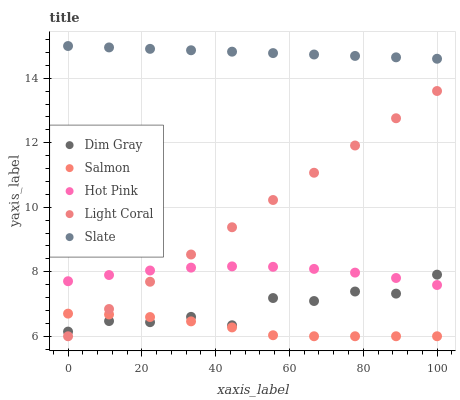Does Salmon have the minimum area under the curve?
Answer yes or no. Yes. Does Slate have the maximum area under the curve?
Answer yes or no. Yes. Does Dim Gray have the minimum area under the curve?
Answer yes or no. No. Does Dim Gray have the maximum area under the curve?
Answer yes or no. No. Is Slate the smoothest?
Answer yes or no. Yes. Is Dim Gray the roughest?
Answer yes or no. Yes. Is Dim Gray the smoothest?
Answer yes or no. No. Is Slate the roughest?
Answer yes or no. No. Does Light Coral have the lowest value?
Answer yes or no. Yes. Does Dim Gray have the lowest value?
Answer yes or no. No. Does Slate have the highest value?
Answer yes or no. Yes. Does Dim Gray have the highest value?
Answer yes or no. No. Is Light Coral less than Slate?
Answer yes or no. Yes. Is Slate greater than Light Coral?
Answer yes or no. Yes. Does Hot Pink intersect Dim Gray?
Answer yes or no. Yes. Is Hot Pink less than Dim Gray?
Answer yes or no. No. Is Hot Pink greater than Dim Gray?
Answer yes or no. No. Does Light Coral intersect Slate?
Answer yes or no. No. 